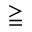Convert formula to latex. <formula><loc_0><loc_0><loc_500><loc_500>\geqq</formula> 